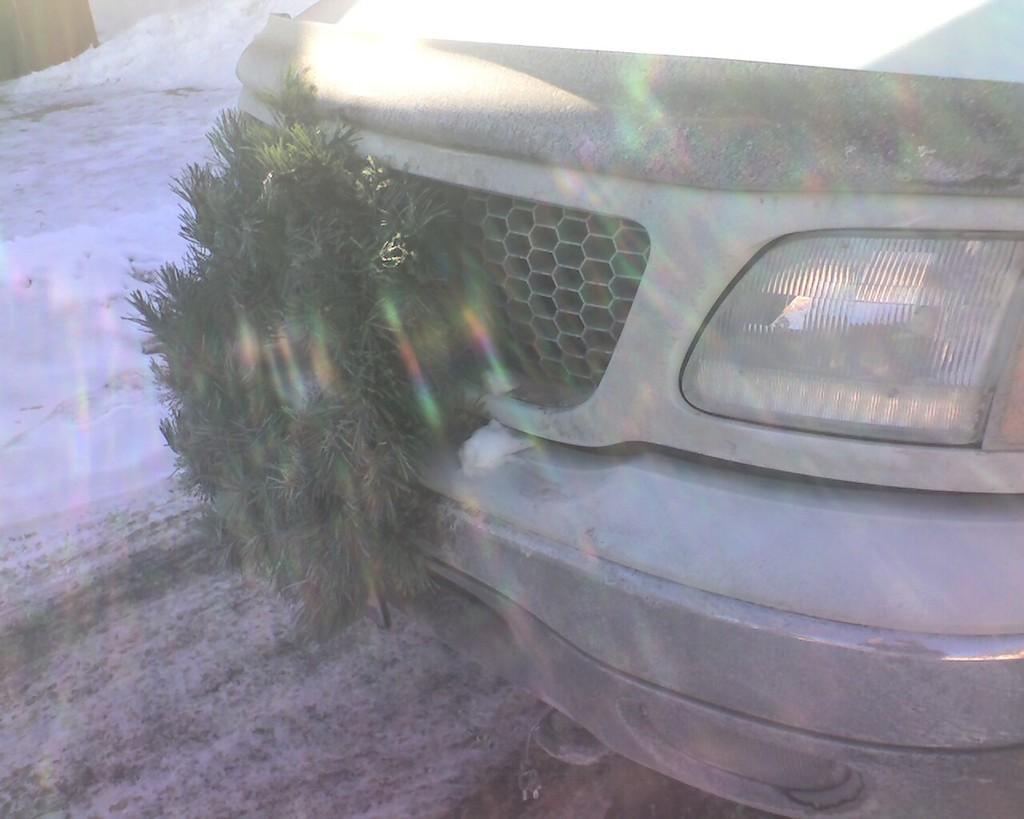Please provide a concise description of this image. In this picture we can see a vehicle on the ground, here we can see leaves and in the background we can see snow and some objects. 